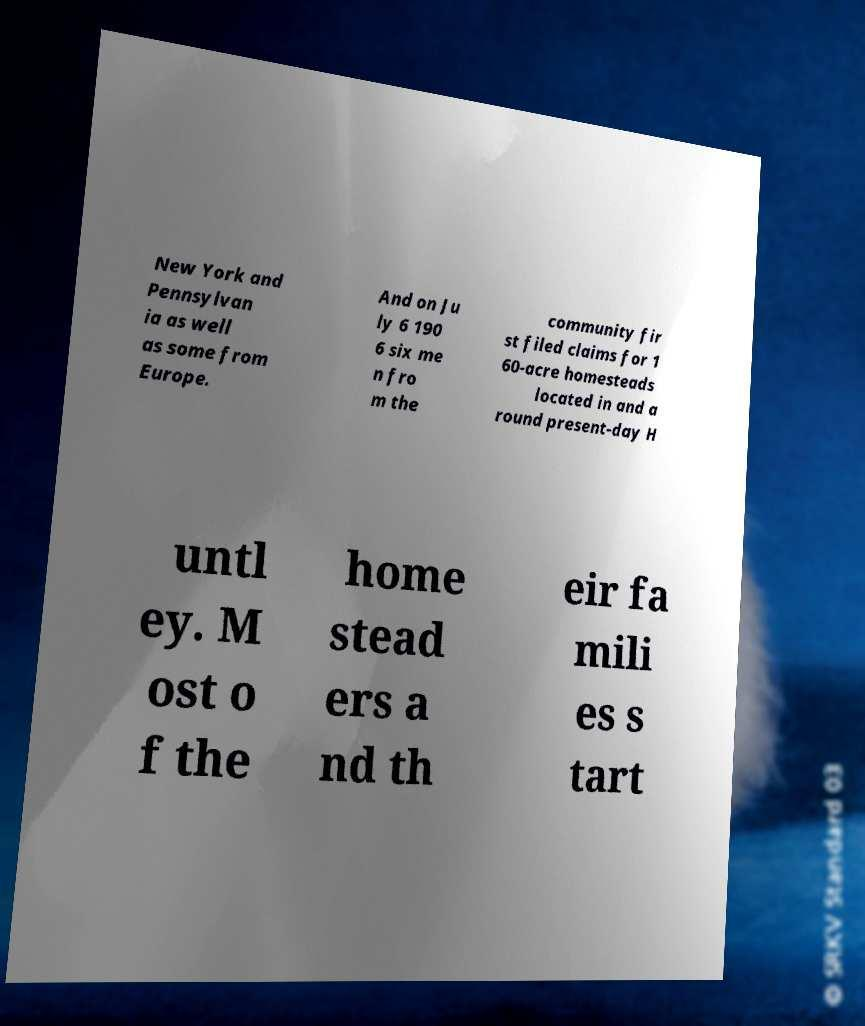What messages or text are displayed in this image? I need them in a readable, typed format. New York and Pennsylvan ia as well as some from Europe. And on Ju ly 6 190 6 six me n fro m the community fir st filed claims for 1 60-acre homesteads located in and a round present-day H untl ey. M ost o f the home stead ers a nd th eir fa mili es s tart 